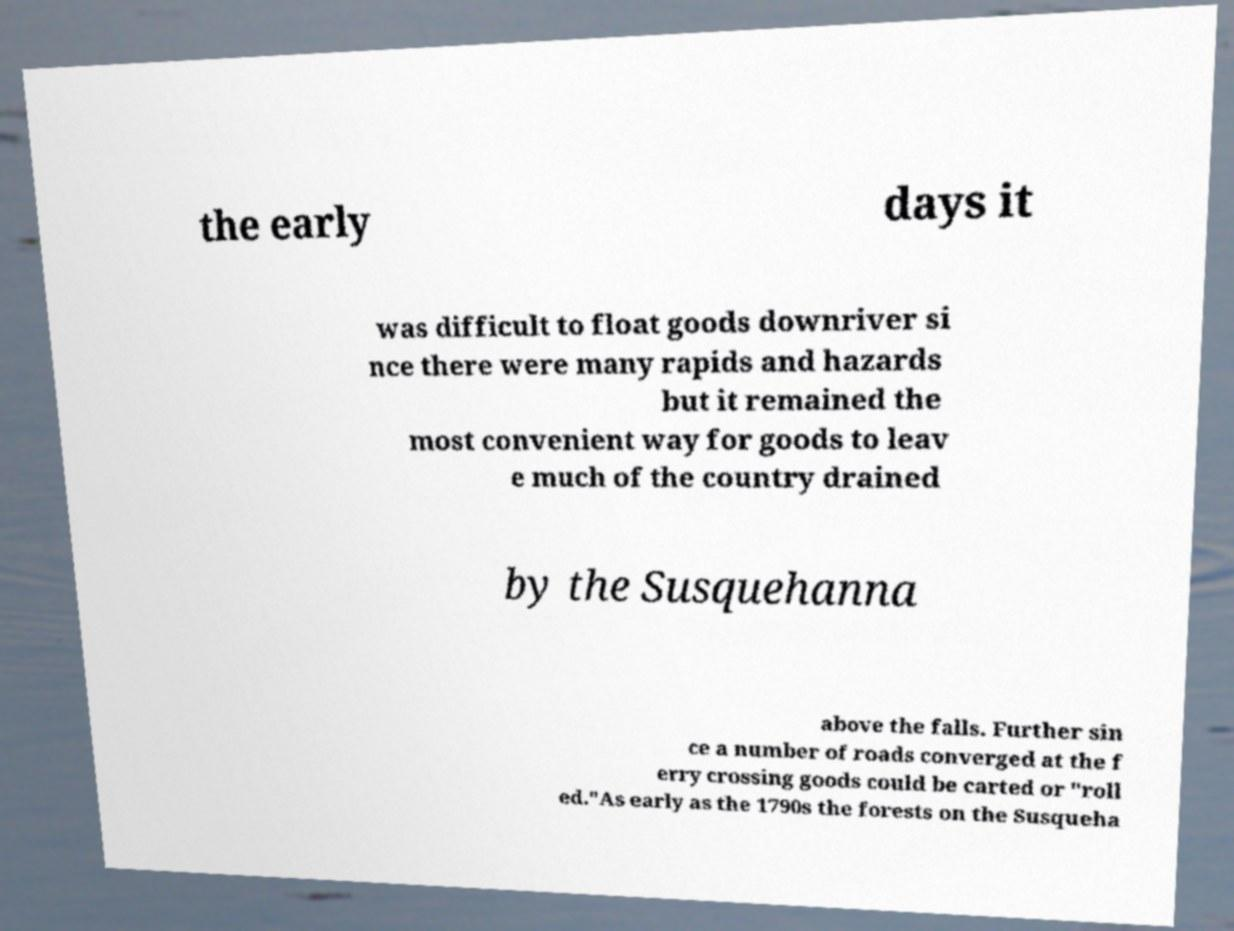Please read and relay the text visible in this image. What does it say? the early days it was difficult to float goods downriver si nce there were many rapids and hazards but it remained the most convenient way for goods to leav e much of the country drained by the Susquehanna above the falls. Further sin ce a number of roads converged at the f erry crossing goods could be carted or "roll ed."As early as the 1790s the forests on the Susqueha 